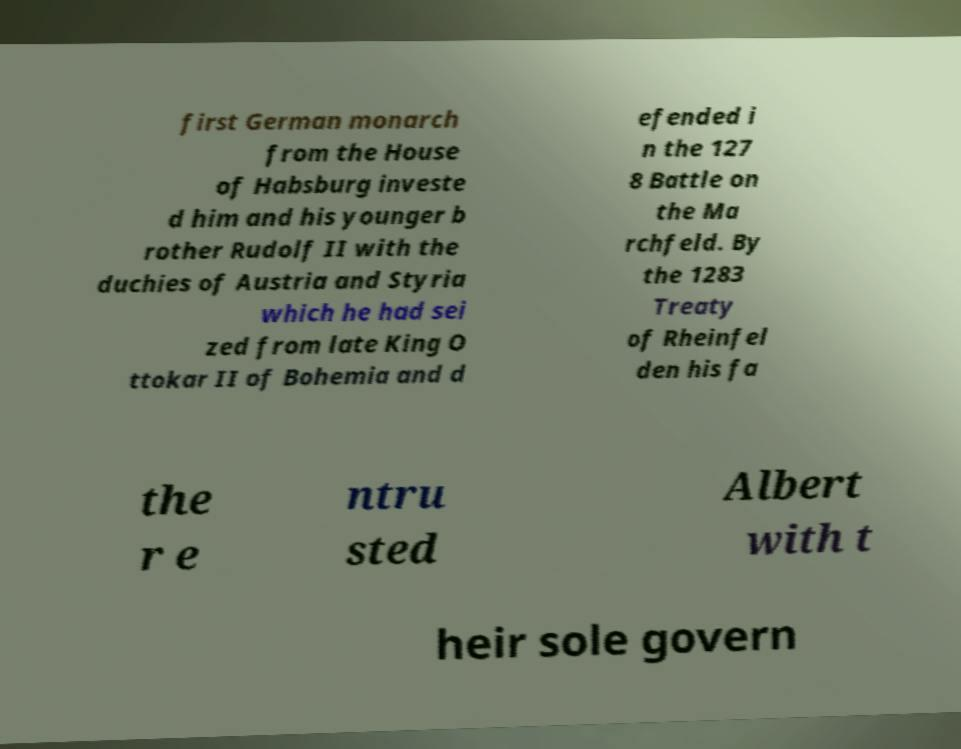Could you extract and type out the text from this image? first German monarch from the House of Habsburg investe d him and his younger b rother Rudolf II with the duchies of Austria and Styria which he had sei zed from late King O ttokar II of Bohemia and d efended i n the 127 8 Battle on the Ma rchfeld. By the 1283 Treaty of Rheinfel den his fa the r e ntru sted Albert with t heir sole govern 